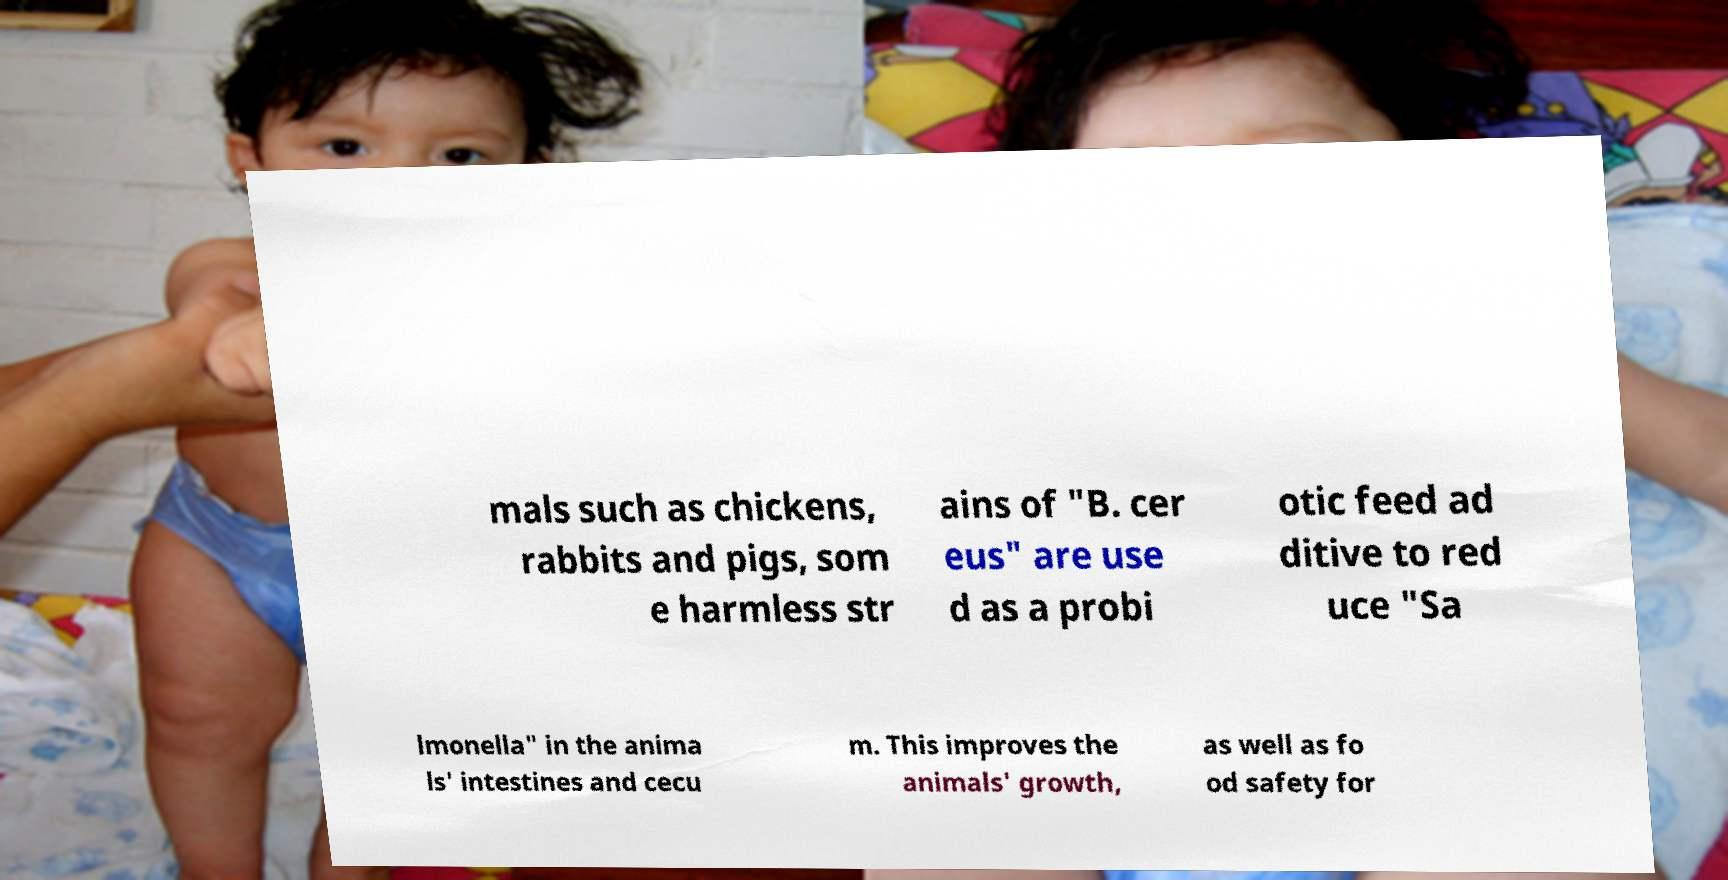What messages or text are displayed in this image? I need them in a readable, typed format. mals such as chickens, rabbits and pigs, som e harmless str ains of "B. cer eus" are use d as a probi otic feed ad ditive to red uce "Sa lmonella" in the anima ls' intestines and cecu m. This improves the animals' growth, as well as fo od safety for 